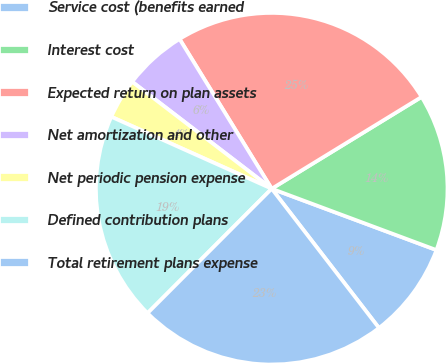Convert chart to OTSL. <chart><loc_0><loc_0><loc_500><loc_500><pie_chart><fcel>Service cost (benefits earned<fcel>Interest cost<fcel>Expected return on plan assets<fcel>Net amortization and other<fcel>Net periodic pension expense<fcel>Defined contribution plans<fcel>Total retirement plans expense<nl><fcel>8.88%<fcel>14.42%<fcel>25.04%<fcel>5.81%<fcel>3.7%<fcel>19.23%<fcel>22.93%<nl></chart> 